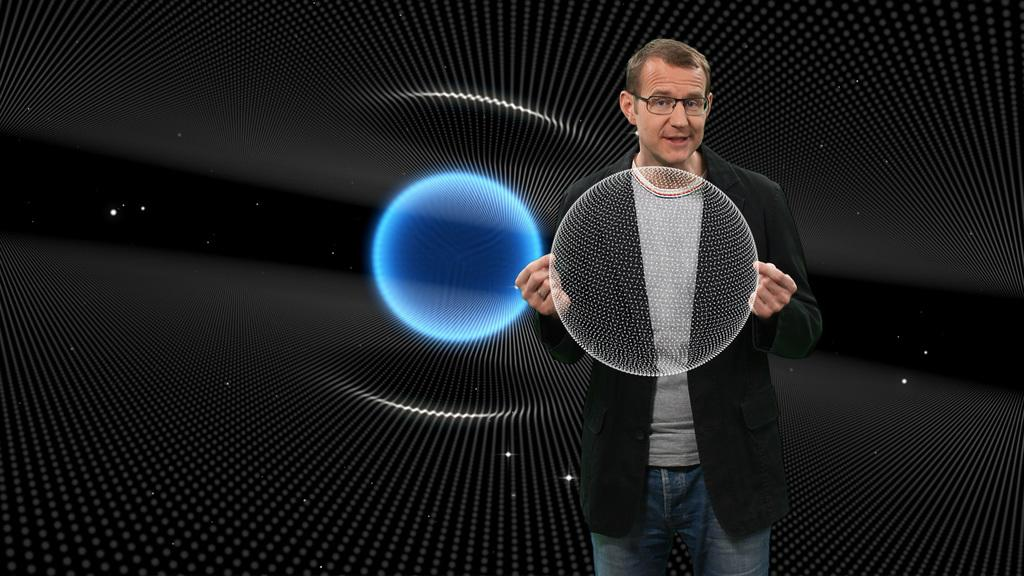What is the main subject of the image? There is a person standing in the center of the image. Can you describe the background of the image? There is a screen in the background of the image. What type of leather is being used to create the stamp in the image? There is no leather or stamp present in the image. Does the existence of the person in the image prove the existence of parallel universes? The presence of a person in the image does not prove the existence of parallel universes, as the image only provides information about the person and the screen in the background. 